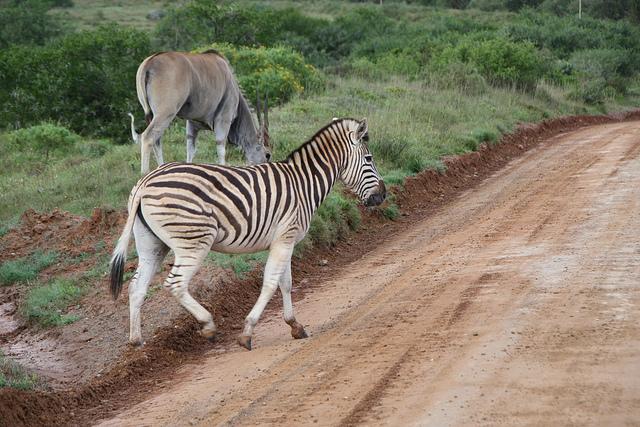How many zebras are in the picture?
Quick response, please. 1. Why did the zebra cross the road?
Be succinct. To get to other side. Are these two animals in a rural area?
Answer briefly. Yes. Are both animals mammals?
Be succinct. Yes. 